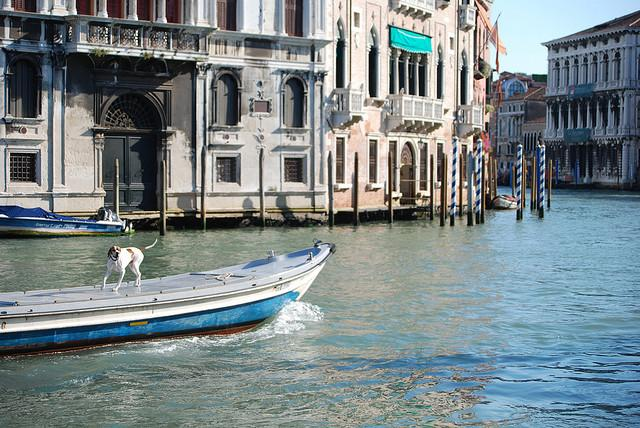What are these waterways equivalent in usage to in other cities and countries?

Choices:
A) streams
B) lakes
C) tarmacs
D) streets streets 